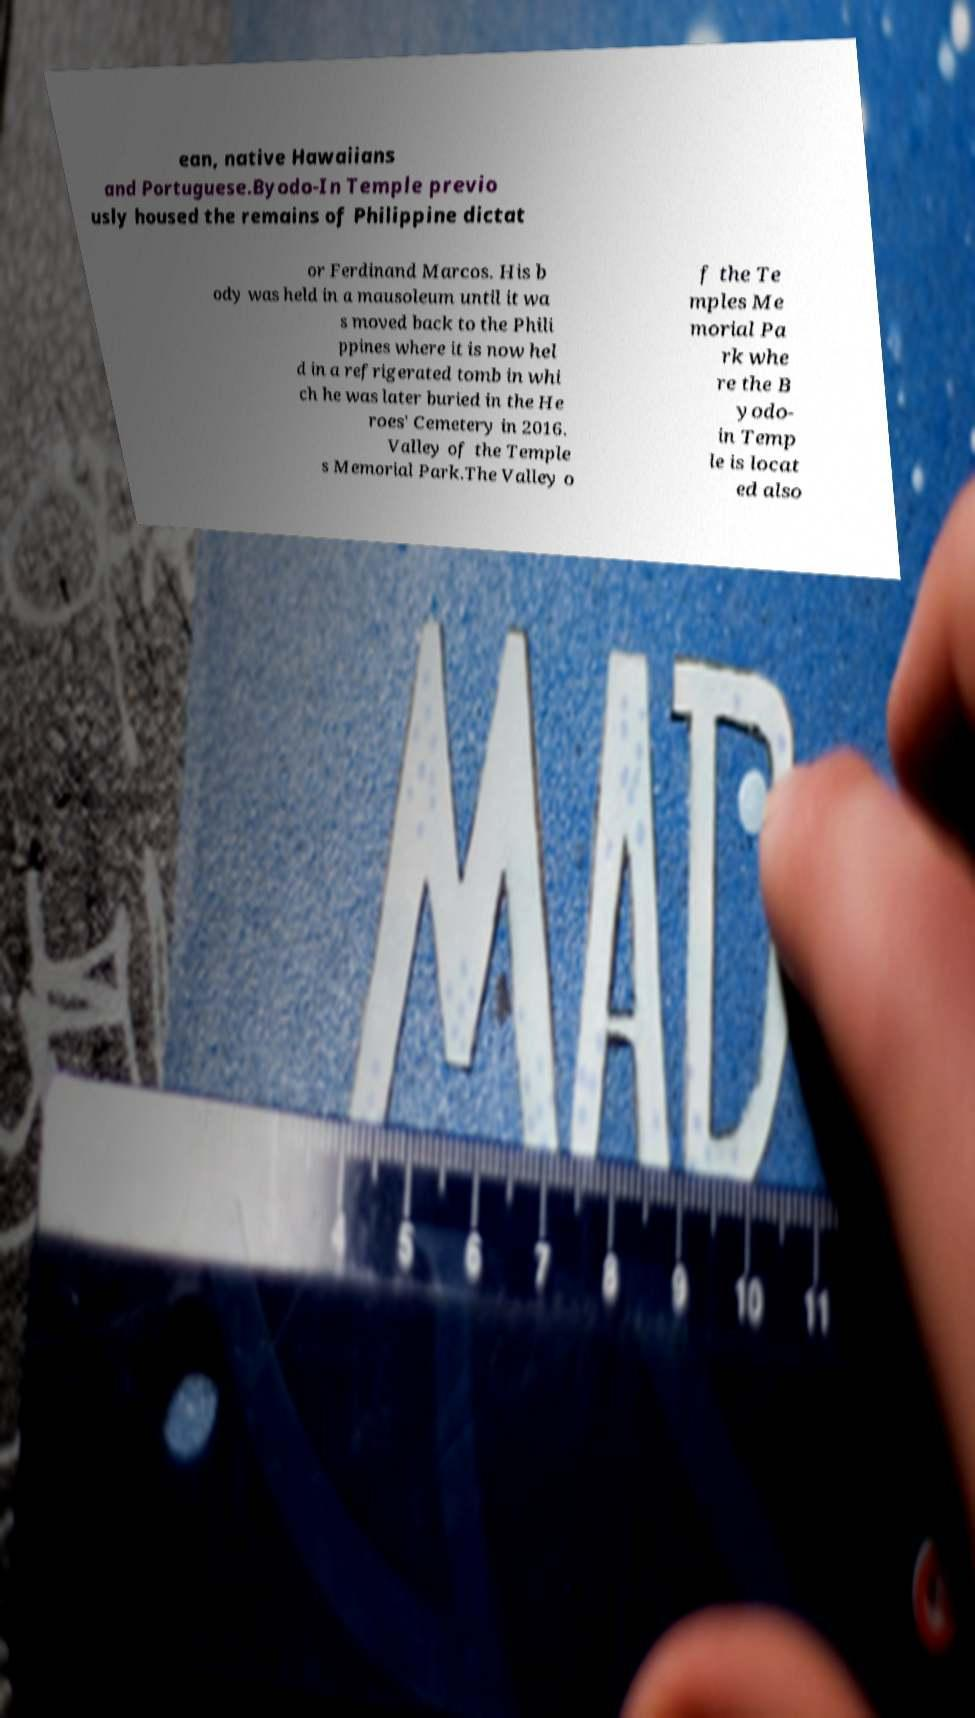Can you accurately transcribe the text from the provided image for me? ean, native Hawaiians and Portuguese.Byodo-In Temple previo usly housed the remains of Philippine dictat or Ferdinand Marcos. His b ody was held in a mausoleum until it wa s moved back to the Phili ppines where it is now hel d in a refrigerated tomb in whi ch he was later buried in the He roes' Cemetery in 2016. Valley of the Temple s Memorial Park.The Valley o f the Te mples Me morial Pa rk whe re the B yodo- in Temp le is locat ed also 